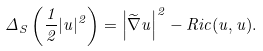<formula> <loc_0><loc_0><loc_500><loc_500>\Delta _ { S } \left ( \frac { 1 } { 2 } | u | ^ { 2 } \right ) = \left | \widetilde { \nabla } u \right | ^ { 2 } - R i c ( u , u ) .</formula> 